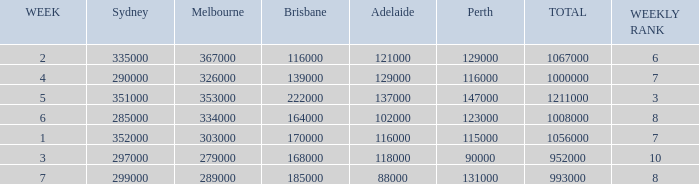How many Adelaide viewers were there in Week 5? 137000.0. 